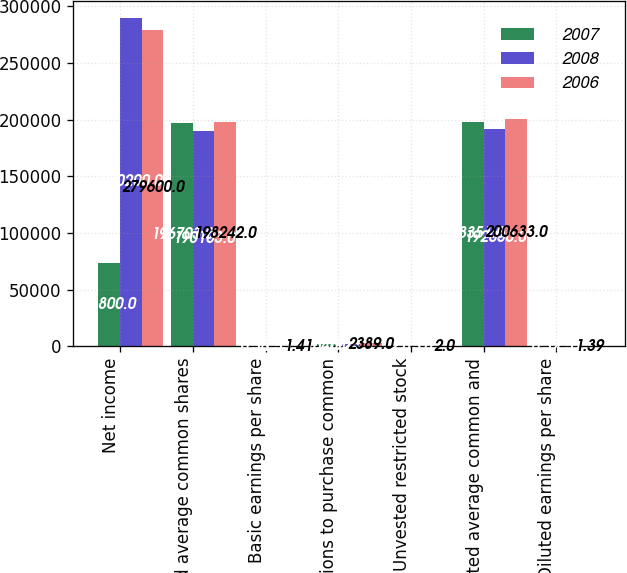Convert chart to OTSL. <chart><loc_0><loc_0><loc_500><loc_500><stacked_bar_chart><ecel><fcel>Net income<fcel>Weighted average common shares<fcel>Basic earnings per share<fcel>Options to purchase common<fcel>Unvested restricted stock<fcel>Weighted average common and<fcel>Diluted earnings per share<nl><fcel>2007<fcel>73800<fcel>196703<fcel>0.38<fcel>1646<fcel>2<fcel>198351<fcel>0.37<nl><fcel>2008<fcel>290200<fcel>190103<fcel>1.53<fcel>1924<fcel>3<fcel>192030<fcel>1.51<nl><fcel>2006<fcel>279600<fcel>198242<fcel>1.41<fcel>2389<fcel>2<fcel>200633<fcel>1.39<nl></chart> 